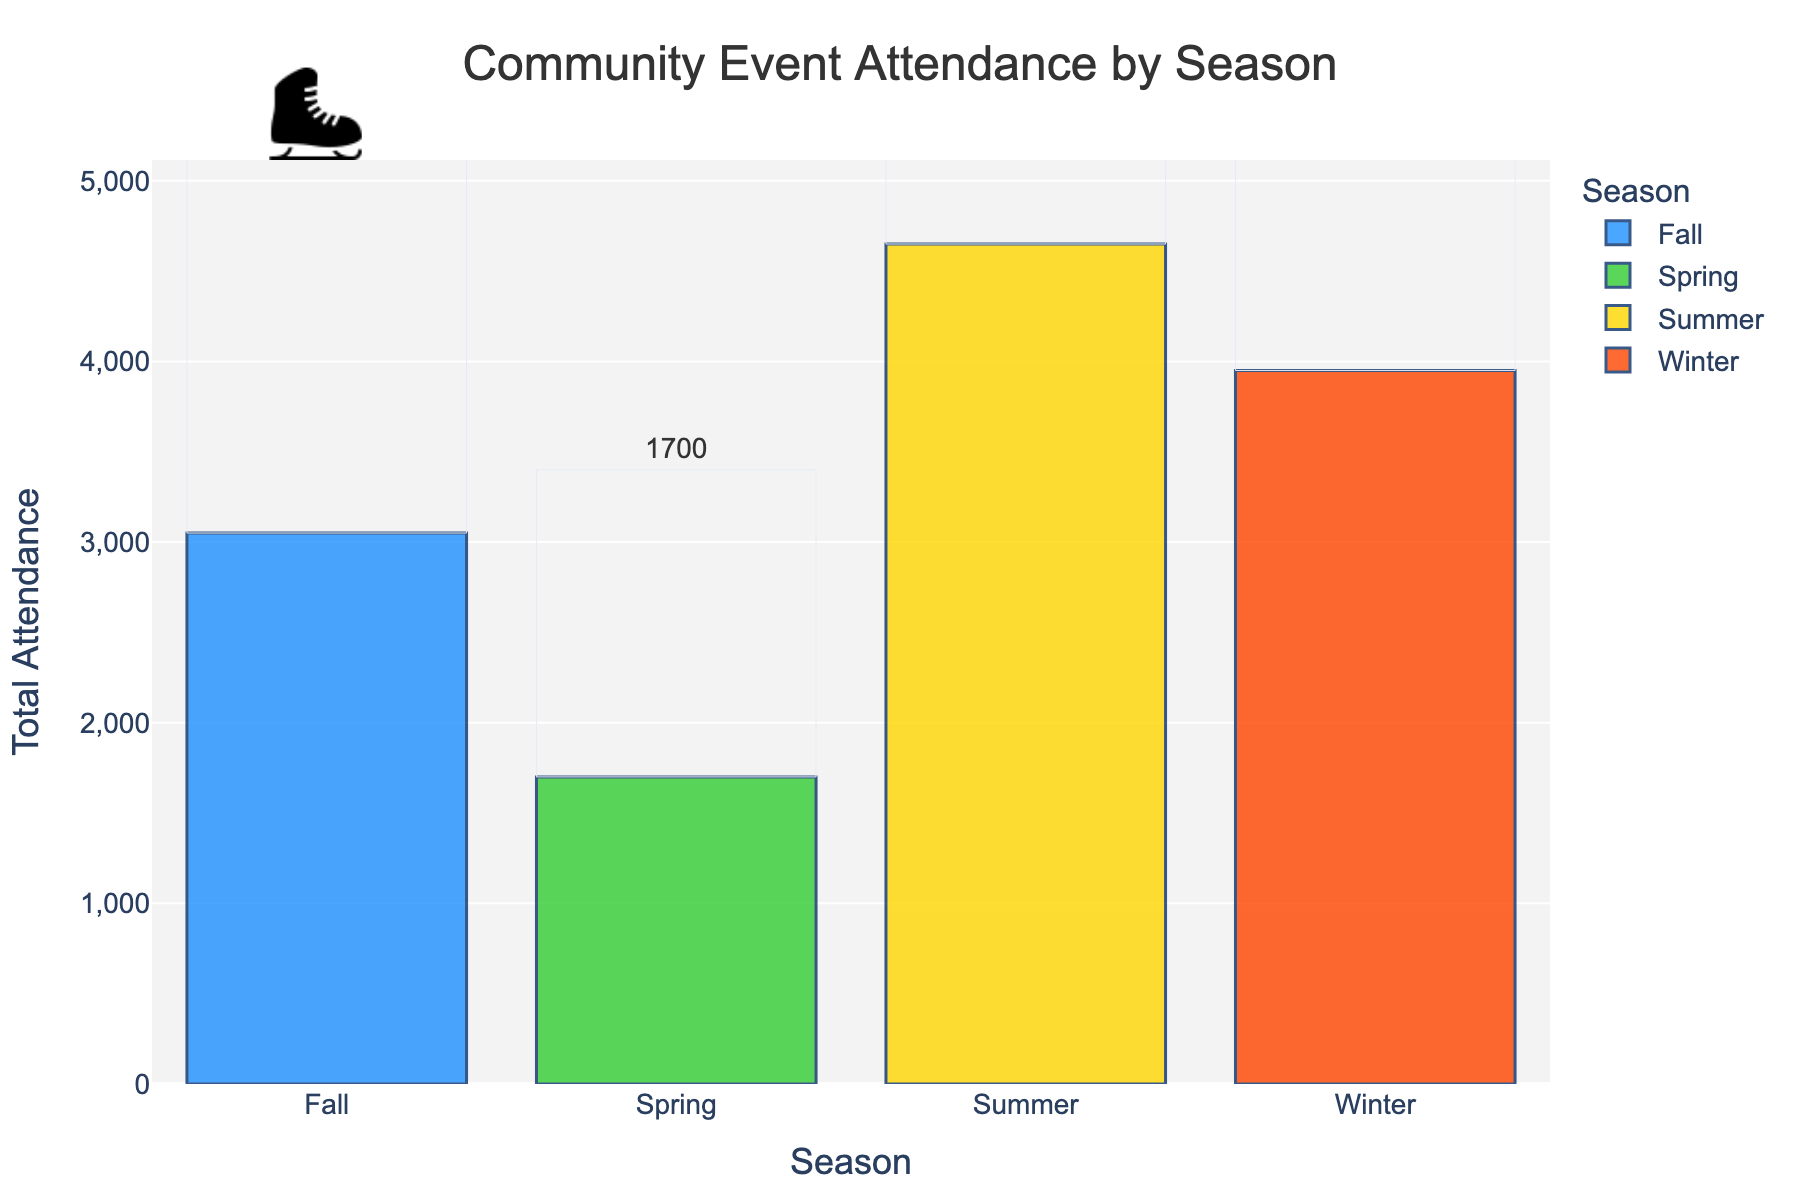Which season had the highest total attendance? The highest total attendance can be determined by looking at the bar with the greatest height. From the bar chart, the tallest bar represents Summer.
Answer: Summer Which event contributed the most to the Winter season's total attendance? To find the event with the highest contribution, check the attendance numbers for Winter events. The New Year's Eve Celebration had the highest attendance with 2000 people.
Answer: New Year's Eve Celebration How much greater is the total attendance in Summer compared to Spring? To find the difference, sum the attendance of Summer events (3500 + 450 + 700 = 4650) and Spring events (300 + 600 + 800 = 1700), then subtract Spring's total from Summer's total: 4650 - 1700.
Answer: 2950 What is the average attendance per season? Find the total attendance for all seasons, then divide by the number of seasons. Total attendance: 750 + 1200 + 2000 + 300 + 600 + 800 + 3500 + 450 + 700 + 1800 + 1000 + 250 = 13350. Divide by 4 seasons: 13350 / 4.
Answer: 3337.5 Which season had the lowest average event attendance? Calculate each season's average by dividing the total attendance by the number of events. Winter: (750 + 1200 + 2000) / 3 = 1316.67, Spring: (300 + 600 + 800) / 3 = 566.67, Summer: (3500 + 450 + 700) / 3 = 1550, Fall: (1800 + 1000 + 250) / 3 = 1016.67. The lowest average is for Spring.
Answer: Spring What percentage of the total annual attendance occurred in Fall? First, find Fall's total attendance (1800 + 1000 + 250 = 3050), then divide by the total attendance for all seasons (13350), and multiply by 100. (3050 / 13350) * 100.
Answer: 22.85% Was the attendance for the Holiday Craft Fair higher or lower than the Farmers Market (average per week)? Compare the attendance figures: Holiday Craft Fair had 1200 attendees and Farmers Market had 700. 1200 is greater than 700.
Answer: Higher Which individual event had the highest attendance? Look at the attendance numbers for all events, the Fourth of July Fireworks in Summer had the highest attendance with 3500 people.
Answer: Fourth of July Fireworks By how much does the total attendance in Winter exceed the total attendance in Fall? Sum the attendance of Winter events (750 + 1200 + 2000 = 3950) and Fall events (1800 + 1000 + 250 = 3050), then subtract Fall's total from Winter's total: 3950 - 3050.
Answer: 900 Which season has a bar colored with a warm hue, such as red or orange? Identify the color hues assigned in the chart. Fall has bars with warm hues, typically represented by colors like red or orange.
Answer: Fall 